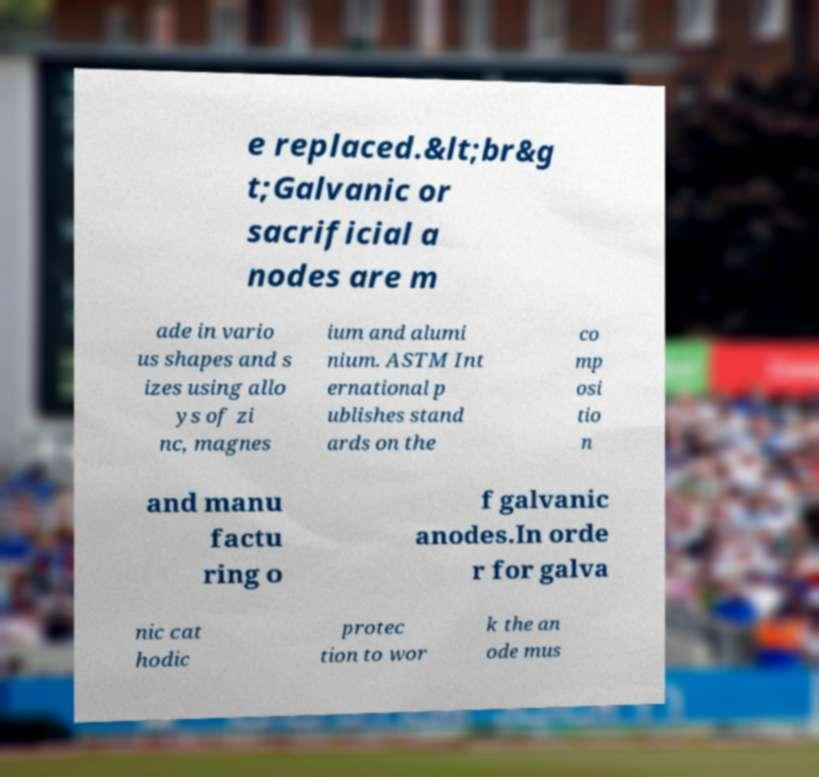I need the written content from this picture converted into text. Can you do that? e replaced.&lt;br&g t;Galvanic or sacrificial a nodes are m ade in vario us shapes and s izes using allo ys of zi nc, magnes ium and alumi nium. ASTM Int ernational p ublishes stand ards on the co mp osi tio n and manu factu ring o f galvanic anodes.In orde r for galva nic cat hodic protec tion to wor k the an ode mus 